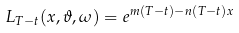Convert formula to latex. <formula><loc_0><loc_0><loc_500><loc_500>L _ { T - t } ( x , \vartheta , \omega ) = e ^ { m ( T - t ) - n ( T - t ) x }</formula> 